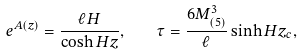<formula> <loc_0><loc_0><loc_500><loc_500>e ^ { A ( z ) } = \frac { \ell H } { \cosh H z } , \quad \tau = \frac { 6 M _ { ( 5 ) } ^ { 3 } } { \ell } \sinh H z _ { c } ,</formula> 